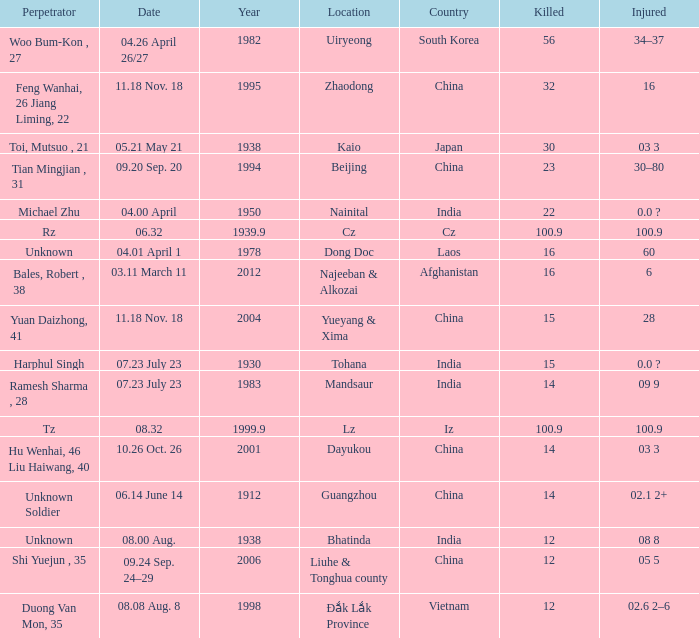01 april 1"? 1978.0. 